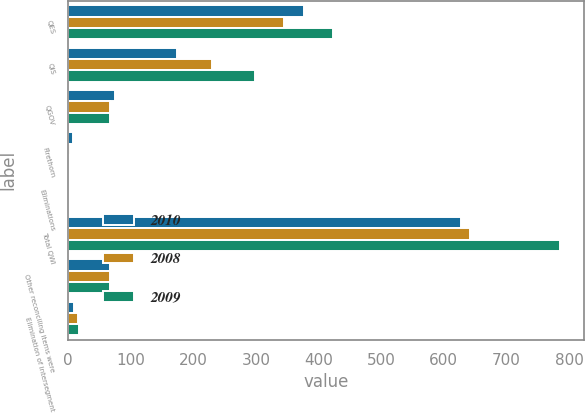Convert chart. <chart><loc_0><loc_0><loc_500><loc_500><stacked_bar_chart><ecel><fcel>QES<fcel>QIS<fcel>QGOV<fcel>Firethorn<fcel>Eliminations<fcel>Total QWI<fcel>Other reconciling items were<fcel>Elimination of intersegment<nl><fcel>2010<fcel>376<fcel>173<fcel>74<fcel>7<fcel>2<fcel>628<fcel>67<fcel>10<nl><fcel>2008<fcel>344<fcel>229<fcel>66<fcel>3<fcel>1<fcel>641<fcel>67<fcel>15<nl><fcel>2009<fcel>423<fcel>299<fcel>67<fcel>2<fcel>2<fcel>785<fcel>67<fcel>18<nl></chart> 